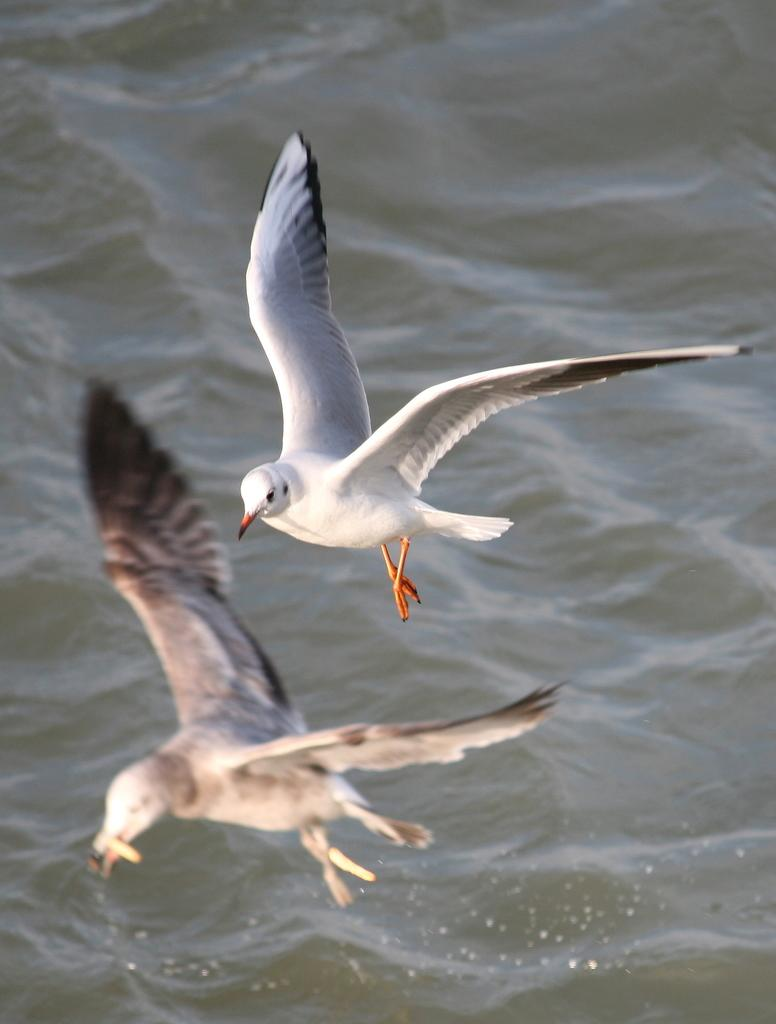What type of animals can be seen in the image? Birds can be seen in the air in the image. What is visible in the image besides the birds? There is water visible in the image. How many lawyers are sitting on the chairs near the hole in the image? There are no lawyers, chairs, or holes present in the image; it features birds in the air and water. 